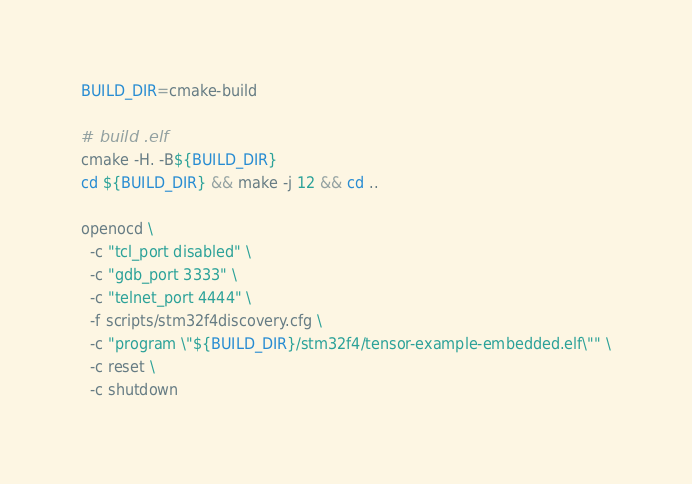Convert code to text. <code><loc_0><loc_0><loc_500><loc_500><_Bash_>BUILD_DIR=cmake-build

# build .elf
cmake -H. -B${BUILD_DIR}
cd ${BUILD_DIR} && make -j 12 && cd ..

openocd \
  -c "tcl_port disabled" \
  -c "gdb_port 3333" \
  -c "telnet_port 4444" \
  -f scripts/stm32f4discovery.cfg \
  -c "program \"${BUILD_DIR}/stm32f4/tensor-example-embedded.elf\"" \
  -c reset \
  -c shutdown
</code> 